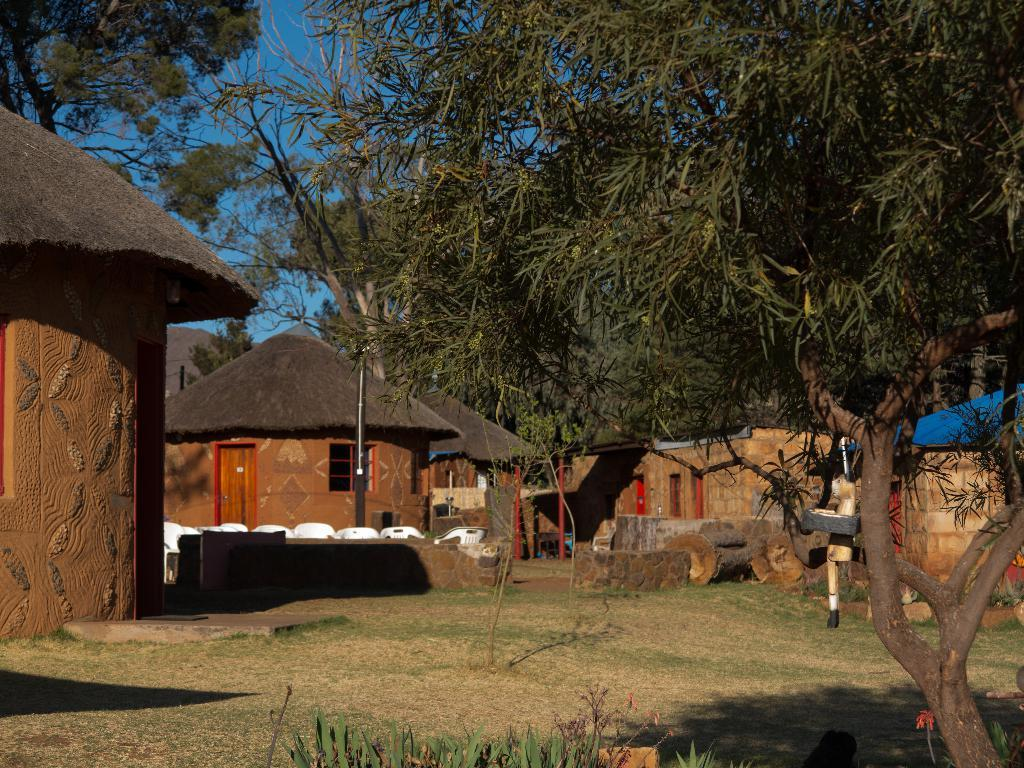What type of structures are present in the image? There are huts in the image. What type of furniture is visible in the image? There are chairs in the image. What type of vegetation is present in the image? There are trees in the image. What is the ground covered with in the image? The ground is covered with grass. What is visible in the background of the image? The sky is visible in the background of the image. What type of payment method is accepted at the huts in the image? There is no information about payment methods in the image; it only shows huts, chairs, trees, grass, and the sky. How many eggs are visible in the image? There are no eggs present in the image. 